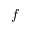Convert formula to latex. <formula><loc_0><loc_0><loc_500><loc_500>f</formula> 